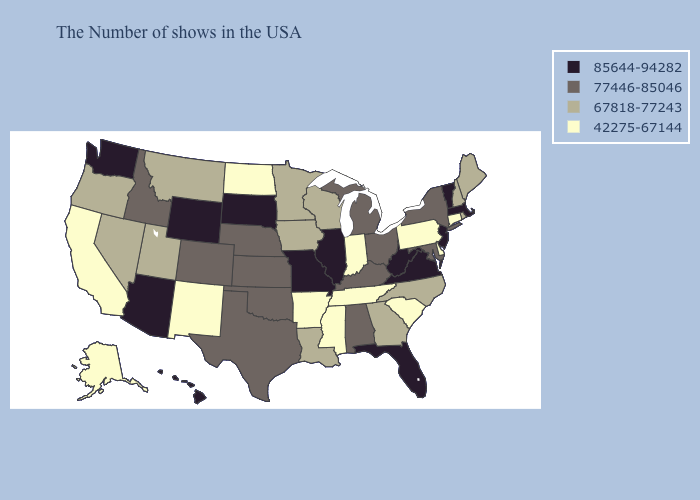What is the lowest value in the USA?
Keep it brief. 42275-67144. Among the states that border Mississippi , does Alabama have the highest value?
Quick response, please. Yes. What is the highest value in the USA?
Give a very brief answer. 85644-94282. Name the states that have a value in the range 67818-77243?
Keep it brief. Maine, Rhode Island, New Hampshire, North Carolina, Georgia, Wisconsin, Louisiana, Minnesota, Iowa, Utah, Montana, Nevada, Oregon. Among the states that border Vermont , which have the highest value?
Answer briefly. Massachusetts. Does Massachusetts have the highest value in the USA?
Give a very brief answer. Yes. Which states hav the highest value in the Northeast?
Write a very short answer. Massachusetts, Vermont, New Jersey. Name the states that have a value in the range 85644-94282?
Quick response, please. Massachusetts, Vermont, New Jersey, Virginia, West Virginia, Florida, Illinois, Missouri, South Dakota, Wyoming, Arizona, Washington, Hawaii. What is the lowest value in states that border Montana?
Write a very short answer. 42275-67144. Name the states that have a value in the range 42275-67144?
Write a very short answer. Connecticut, Delaware, Pennsylvania, South Carolina, Indiana, Tennessee, Mississippi, Arkansas, North Dakota, New Mexico, California, Alaska. What is the highest value in states that border Rhode Island?
Give a very brief answer. 85644-94282. What is the value of Wisconsin?
Concise answer only. 67818-77243. Does Idaho have a higher value than Kansas?
Concise answer only. No. What is the value of Alaska?
Answer briefly. 42275-67144. What is the highest value in the USA?
Give a very brief answer. 85644-94282. 